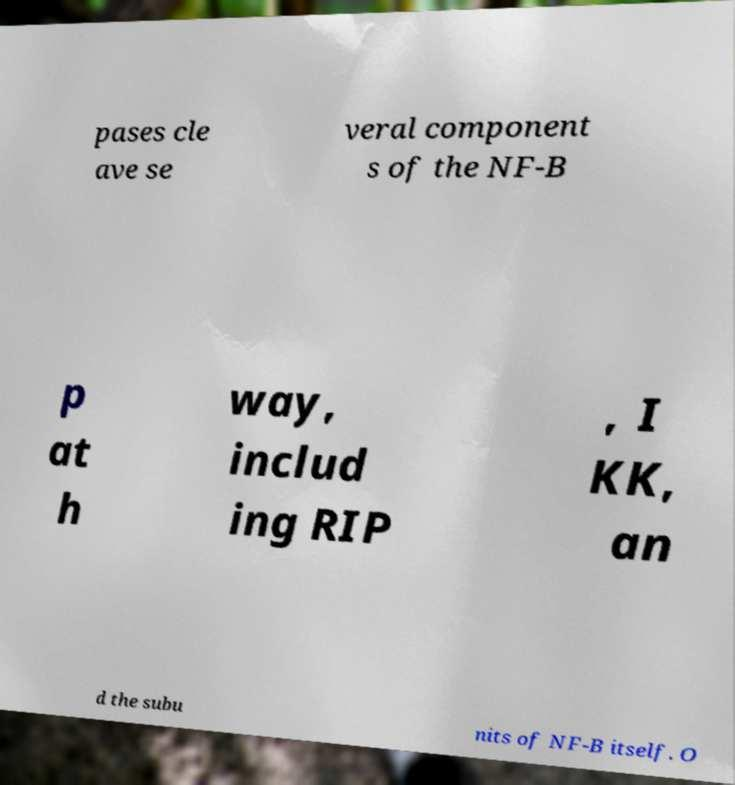I need the written content from this picture converted into text. Can you do that? pases cle ave se veral component s of the NF-B p at h way, includ ing RIP , I KK, an d the subu nits of NF-B itself. O 